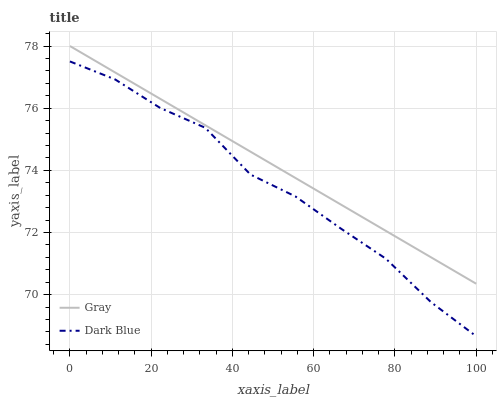Does Dark Blue have the minimum area under the curve?
Answer yes or no. Yes. Does Gray have the maximum area under the curve?
Answer yes or no. Yes. Does Dark Blue have the maximum area under the curve?
Answer yes or no. No. Is Gray the smoothest?
Answer yes or no. Yes. Is Dark Blue the roughest?
Answer yes or no. Yes. Is Dark Blue the smoothest?
Answer yes or no. No. Does Gray have the highest value?
Answer yes or no. Yes. Does Dark Blue have the highest value?
Answer yes or no. No. Is Dark Blue less than Gray?
Answer yes or no. Yes. Is Gray greater than Dark Blue?
Answer yes or no. Yes. Does Dark Blue intersect Gray?
Answer yes or no. No. 